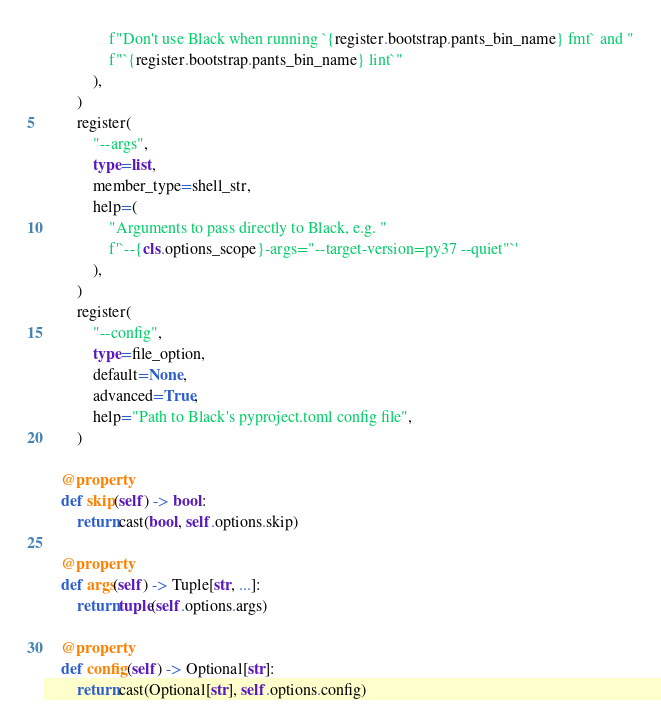Convert code to text. <code><loc_0><loc_0><loc_500><loc_500><_Python_>                f"Don't use Black when running `{register.bootstrap.pants_bin_name} fmt` and "
                f"`{register.bootstrap.pants_bin_name} lint`"
            ),
        )
        register(
            "--args",
            type=list,
            member_type=shell_str,
            help=(
                "Arguments to pass directly to Black, e.g. "
                f'`--{cls.options_scope}-args="--target-version=py37 --quiet"`'
            ),
        )
        register(
            "--config",
            type=file_option,
            default=None,
            advanced=True,
            help="Path to Black's pyproject.toml config file",
        )

    @property
    def skip(self) -> bool:
        return cast(bool, self.options.skip)

    @property
    def args(self) -> Tuple[str, ...]:
        return tuple(self.options.args)

    @property
    def config(self) -> Optional[str]:
        return cast(Optional[str], self.options.config)
</code> 